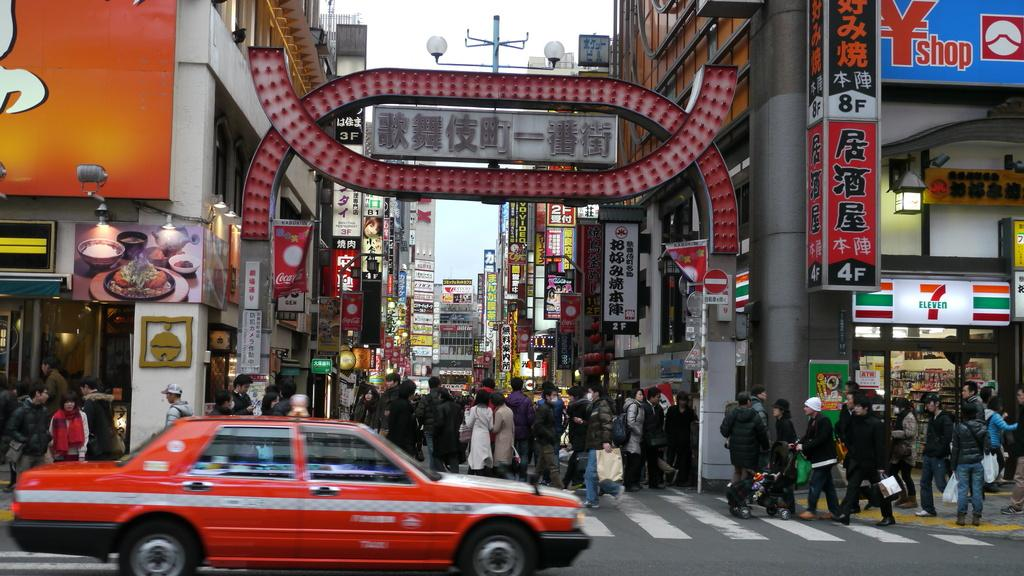Provide a one-sentence caption for the provided image. A crowded street in front of a 7 Eleven and some Coca Cola banners. 